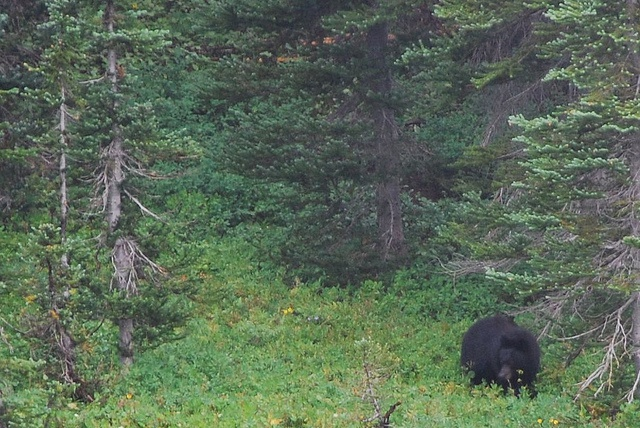Describe the objects in this image and their specific colors. I can see a bear in black and gray tones in this image. 